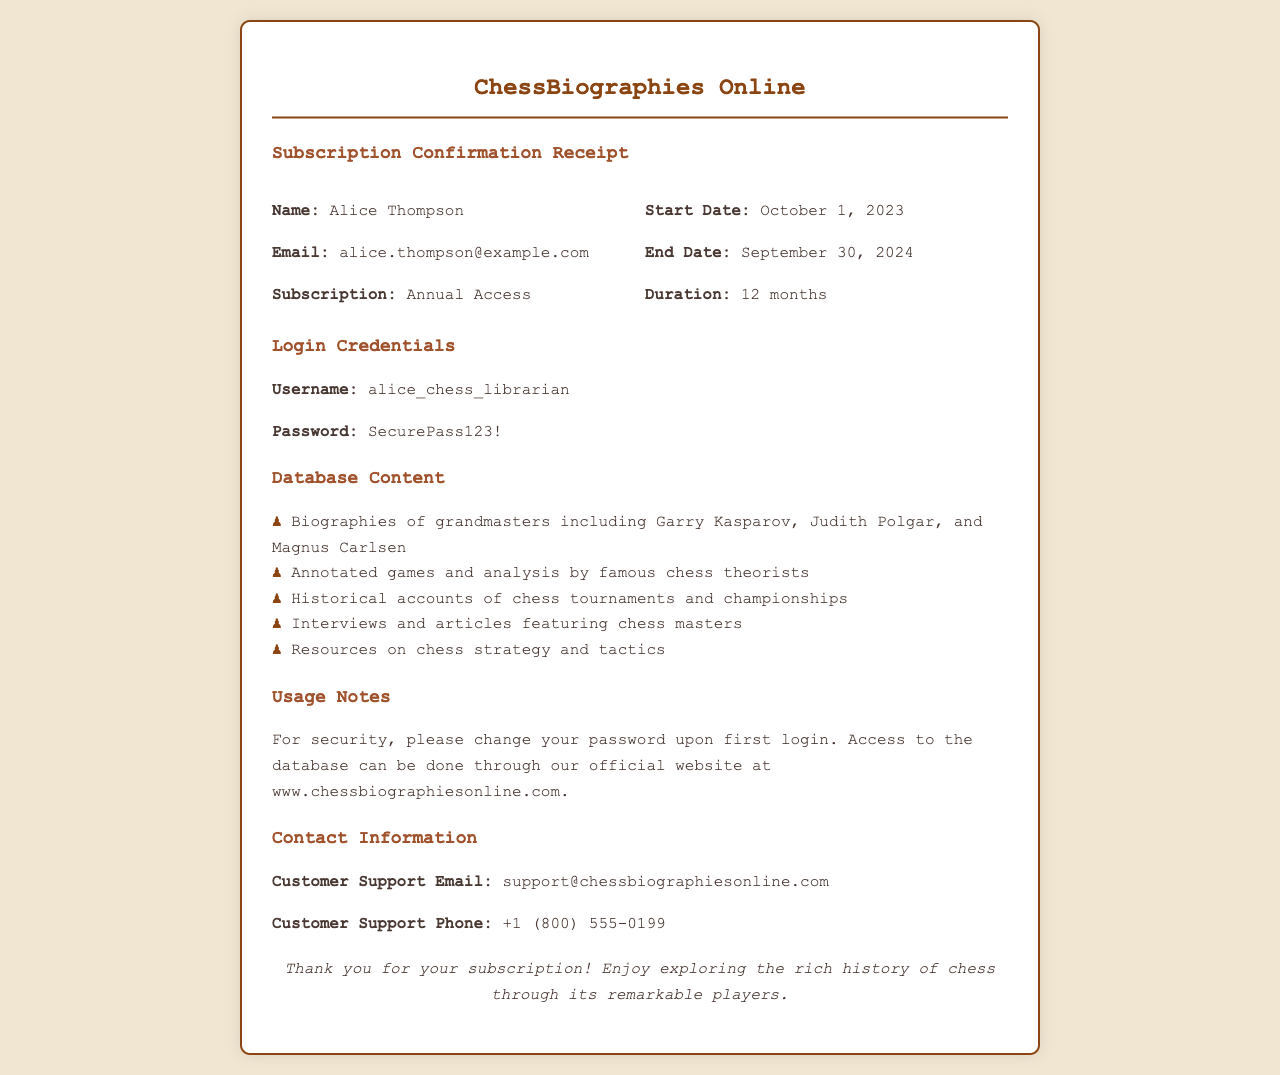What is the name of the subscriber? The name of the subscriber is displayed prominently in the receipt under the name section.
Answer: Alice Thompson What is the start date of the subscription? The start date is listed in the details section of the receipt.
Answer: October 1, 2023 What is the subscription duration? The duration indicates how long the subscription is valid, shown in the details section.
Answer: 12 months What is the username for login? The username is specifically mentioned in the login credentials section of the receipt.
Answer: alice_chess_librarian What is the end date of the subscription? The end date shows when the subscription will expire and is located in the details section.
Answer: September 30, 2024 How many grandmasters are mentioned in the database content? The number of grandmasters can be inferred from the list of biographies included in the database content section.
Answer: Three What should be done for security upon first login? This information is a specific instruction provided for user security in the usage notes.
Answer: Change password What is the customer support email? This information is provided in the contact information section for subscriber assistance.
Answer: support@chessbiographiesonline.com What type of access was purchased? The subscription type is outlined in the details section of the receipt.
Answer: Annual Access 